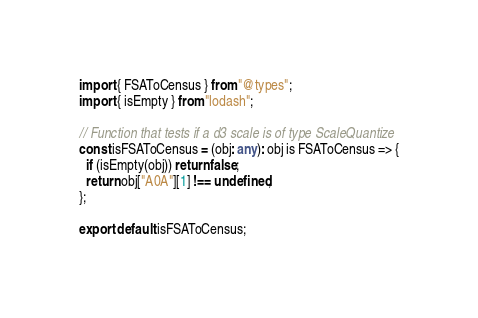<code> <loc_0><loc_0><loc_500><loc_500><_TypeScript_>import { FSAToCensus } from "@types";
import { isEmpty } from "lodash";

// Function that tests if a d3 scale is of type ScaleQuantize
const isFSAToCensus = (obj: any): obj is FSAToCensus => {
  if (isEmpty(obj)) return false;
  return obj["A0A"][1] !== undefined;
};

export default isFSAToCensus;
</code> 